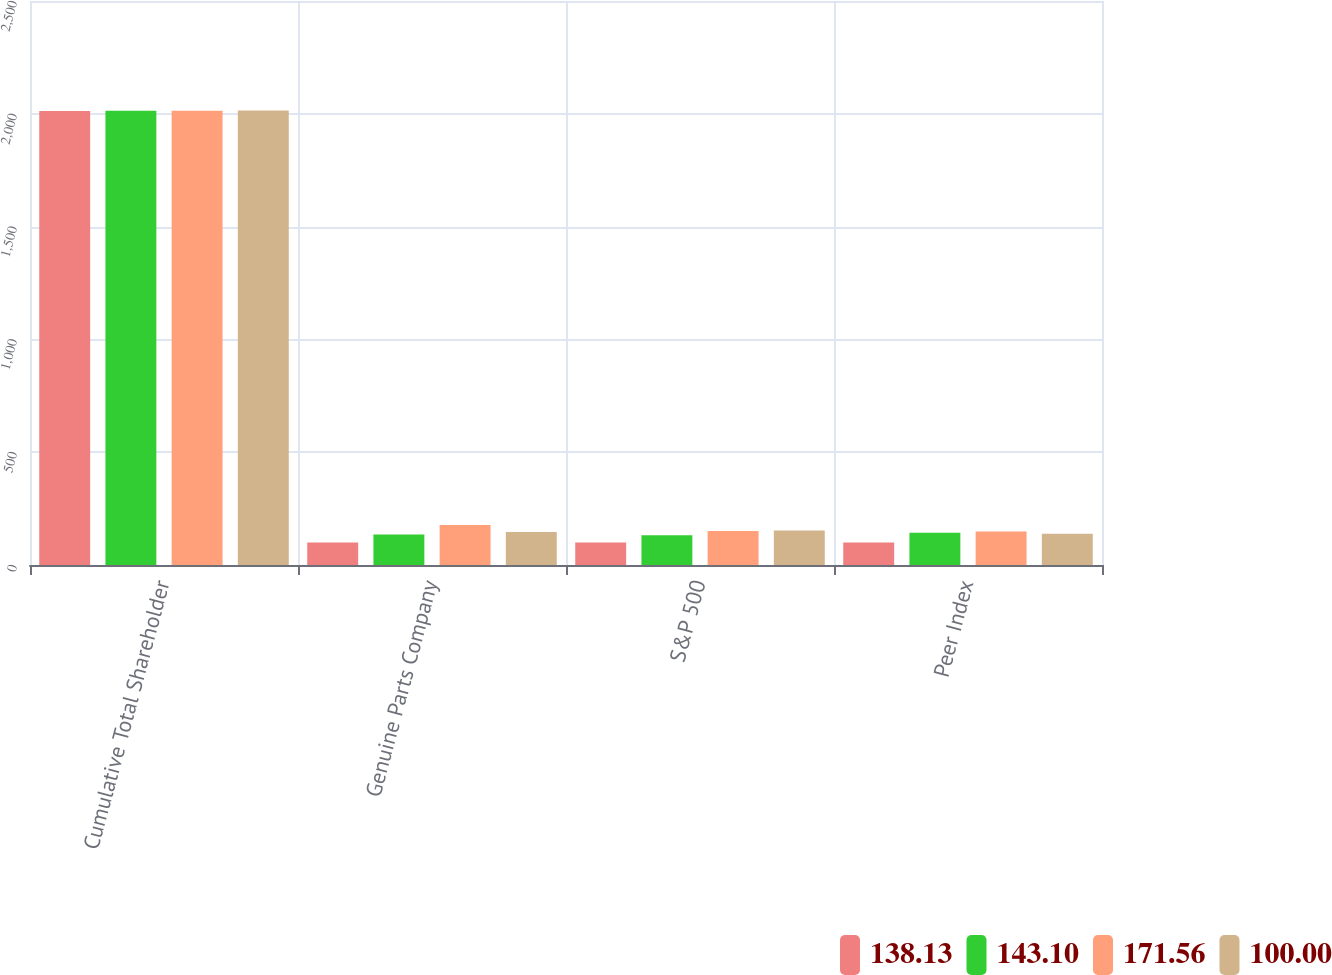Convert chart. <chart><loc_0><loc_0><loc_500><loc_500><stacked_bar_chart><ecel><fcel>Cumulative Total Shareholder<fcel>Genuine Parts Company<fcel>S&P 500<fcel>Peer Index<nl><fcel>138.13<fcel>2012<fcel>100<fcel>100<fcel>100<nl><fcel>143.1<fcel>2013<fcel>134.71<fcel>132.39<fcel>143.1<nl><fcel>171.56<fcel>2014<fcel>177.18<fcel>150.51<fcel>148.58<nl><fcel>100<fcel>2015<fcel>146.63<fcel>152.59<fcel>138.13<nl></chart> 